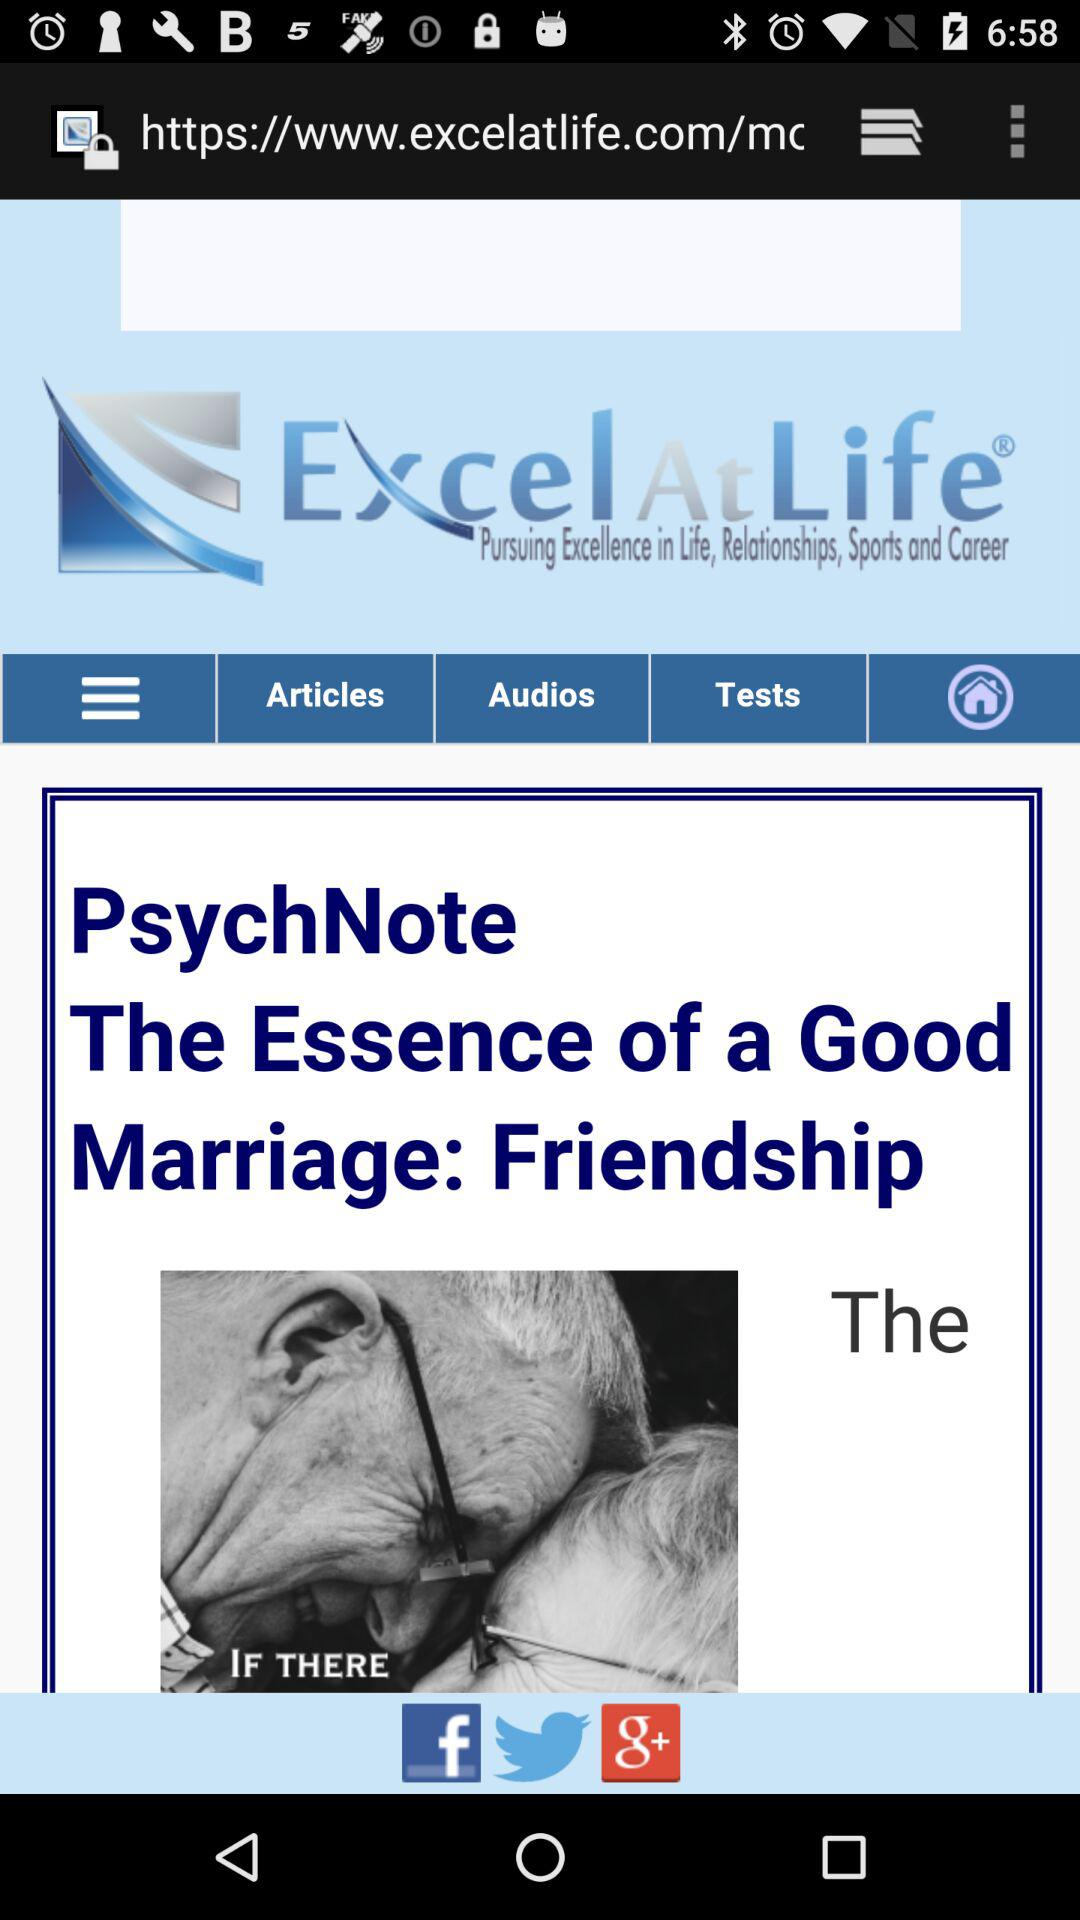What is the name of the application? The name of the application is "Excel At Life Ad-Free Support". 